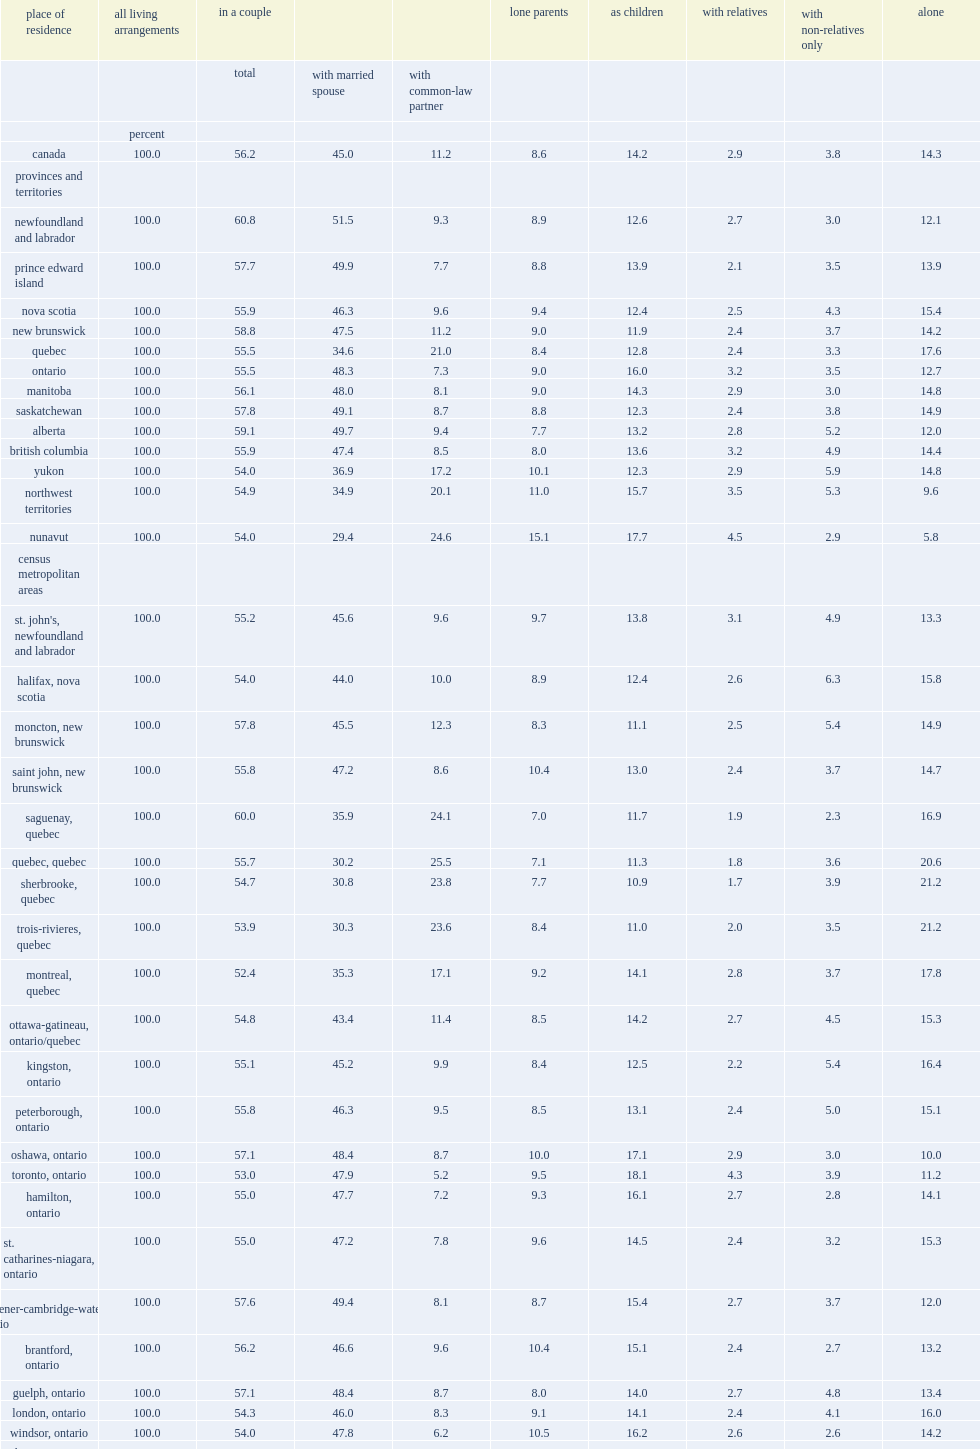How many percentage points of women in common-law unions did numavut have in 2011? 24.6. How many percentage points of women in common-law unions did northwest territories have in 2011? 20.1. How many percentage points of women living with a common-law parter did quebec have in 2011? 21.0. How many percentage points of women living with a common-law parter did saguenay have in 2011? 24.1. How many percentage points of women living with a common-law parter did sherbrooke have in 2011? 23.8. How many percentage points of women living with a common-law parter did trois-rivieres have in 2011? 23.6. How many percentage points did women in montreal live with a common-law parter in 2011? 17.1. 